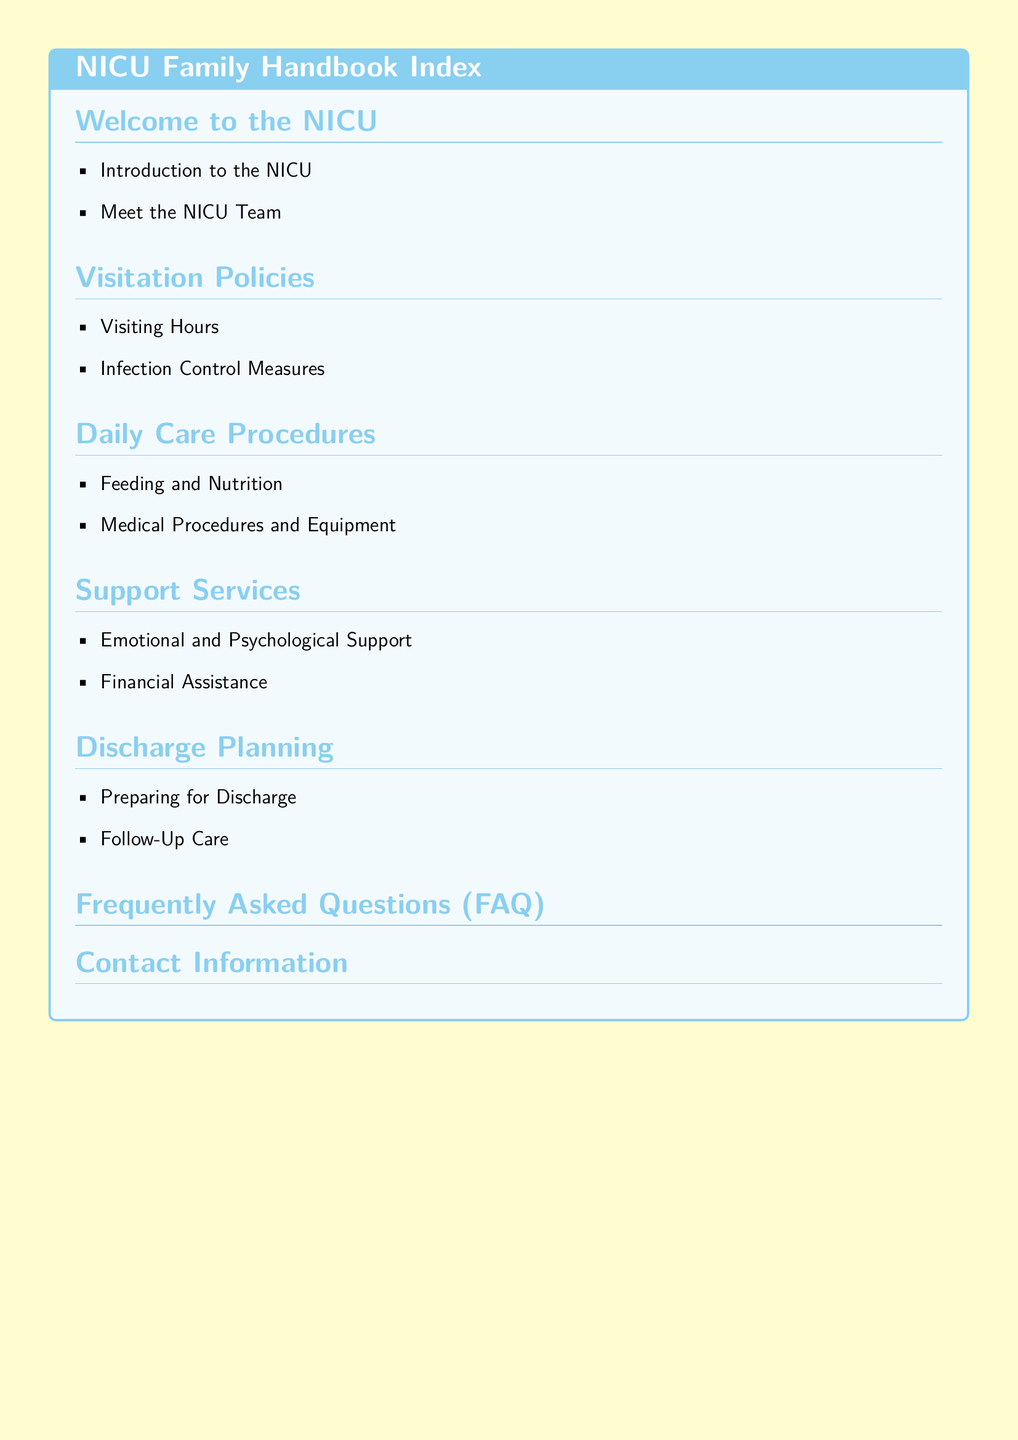What is the section title for visiting guidelines? The section title related to visiting guidelines is explicitly labeled "Visitation Policies."
Answer: Visitation Policies How many main sections are in the NICU Family Handbook? The document outlines a total of six main sections including "Welcome to the NICU," "Visitation Policies," "Daily Care Procedures," "Support Services," "Discharge Planning," and "Frequently Asked Questions."
Answer: Six What type of support is included in the Support Services section? The Support Services section explicitly mentions "Emotional and Psychological Support" and "Financial Assistance."
Answer: Emotional and Psychological Support, Financial Assistance What is covered under Daily Care Procedures? The Daily Care Procedures section includes "Feeding and Nutrition" and "Medical Procedures and Equipment," indicating the focus on care methods in the NICU.
Answer: Feeding and Nutrition, Medical Procedures and Equipment What is the main purpose of the Discharge Planning section? The Discharge Planning section is designed to address both "Preparing for Discharge" and "Follow-Up Care," which are critical for families transitioning out of the NICU.
Answer: Preparing for Discharge, Follow-Up Care What color theme is used in the NICU Family Handbook? The NICU Family Handbook features a soft yellow background with elements in baby blue, making it visually appealing and calming for families.
Answer: Soft yellow, baby blue 